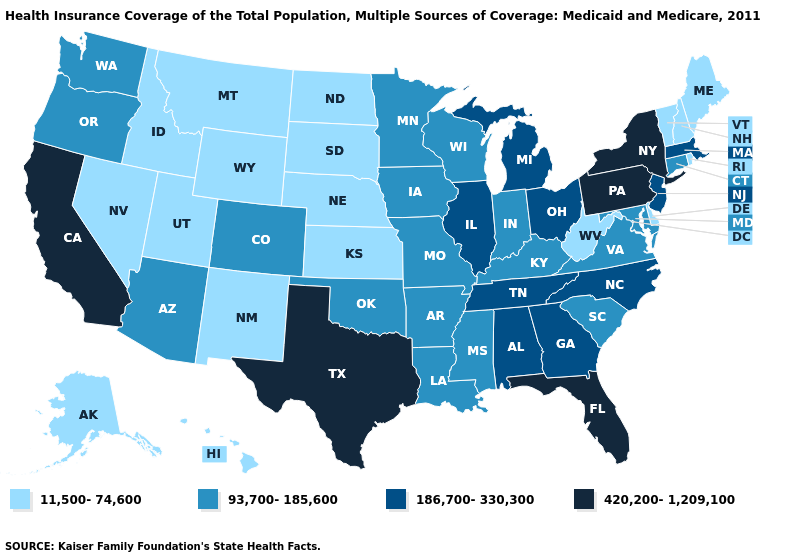Name the states that have a value in the range 11,500-74,600?
Quick response, please. Alaska, Delaware, Hawaii, Idaho, Kansas, Maine, Montana, Nebraska, Nevada, New Hampshire, New Mexico, North Dakota, Rhode Island, South Dakota, Utah, Vermont, West Virginia, Wyoming. Does Massachusetts have the highest value in the USA?
Quick response, please. No. What is the value of Illinois?
Concise answer only. 186,700-330,300. Name the states that have a value in the range 420,200-1,209,100?
Keep it brief. California, Florida, New York, Pennsylvania, Texas. What is the value of Nebraska?
Write a very short answer. 11,500-74,600. Does the map have missing data?
Short answer required. No. What is the highest value in the USA?
Keep it brief. 420,200-1,209,100. Does Vermont have the lowest value in the Northeast?
Answer briefly. Yes. What is the highest value in the USA?
Give a very brief answer. 420,200-1,209,100. Name the states that have a value in the range 11,500-74,600?
Short answer required. Alaska, Delaware, Hawaii, Idaho, Kansas, Maine, Montana, Nebraska, Nevada, New Hampshire, New Mexico, North Dakota, Rhode Island, South Dakota, Utah, Vermont, West Virginia, Wyoming. Name the states that have a value in the range 186,700-330,300?
Answer briefly. Alabama, Georgia, Illinois, Massachusetts, Michigan, New Jersey, North Carolina, Ohio, Tennessee. Does North Dakota have the lowest value in the USA?
Quick response, please. Yes. What is the value of Arizona?
Concise answer only. 93,700-185,600. Name the states that have a value in the range 186,700-330,300?
Be succinct. Alabama, Georgia, Illinois, Massachusetts, Michigan, New Jersey, North Carolina, Ohio, Tennessee. Does the map have missing data?
Concise answer only. No. 